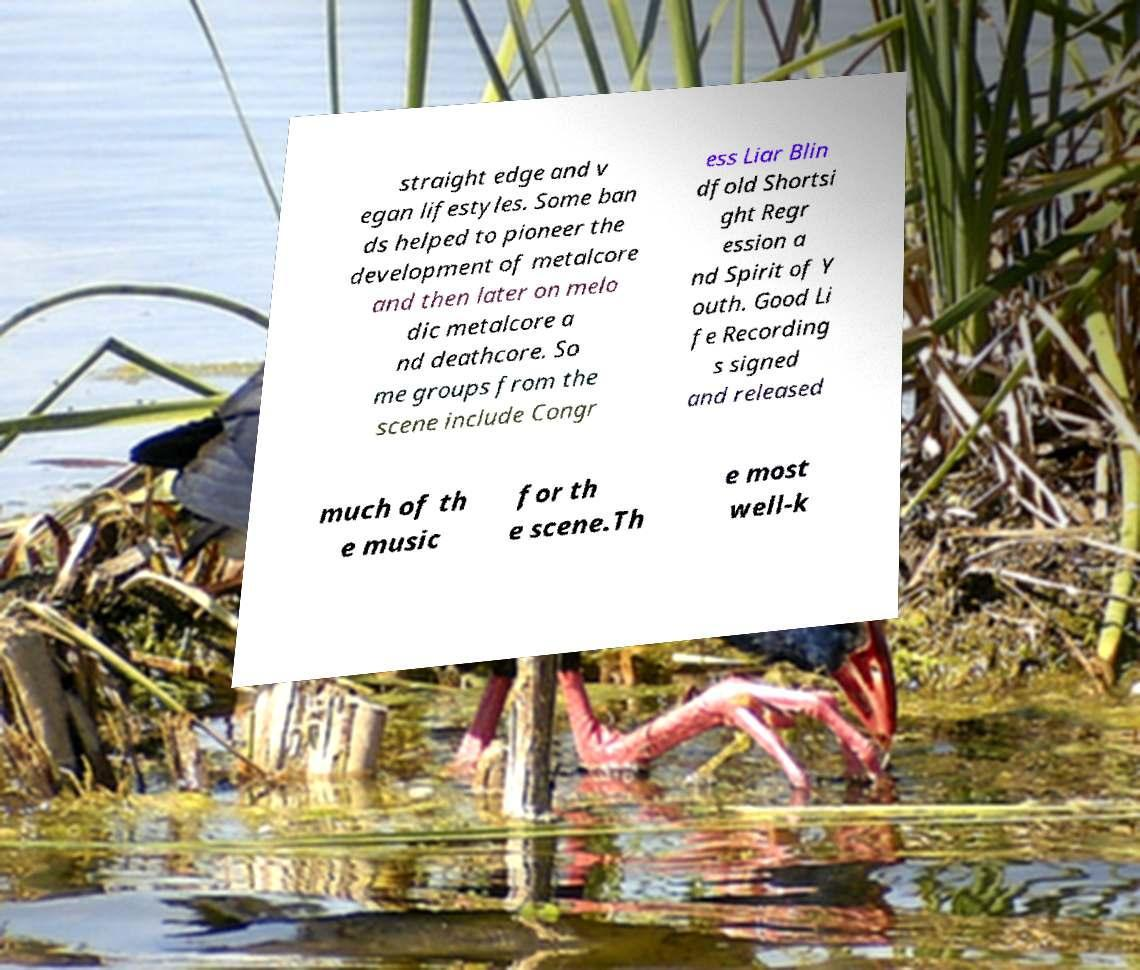Please identify and transcribe the text found in this image. straight edge and v egan lifestyles. Some ban ds helped to pioneer the development of metalcore and then later on melo dic metalcore a nd deathcore. So me groups from the scene include Congr ess Liar Blin dfold Shortsi ght Regr ession a nd Spirit of Y outh. Good Li fe Recording s signed and released much of th e music for th e scene.Th e most well-k 